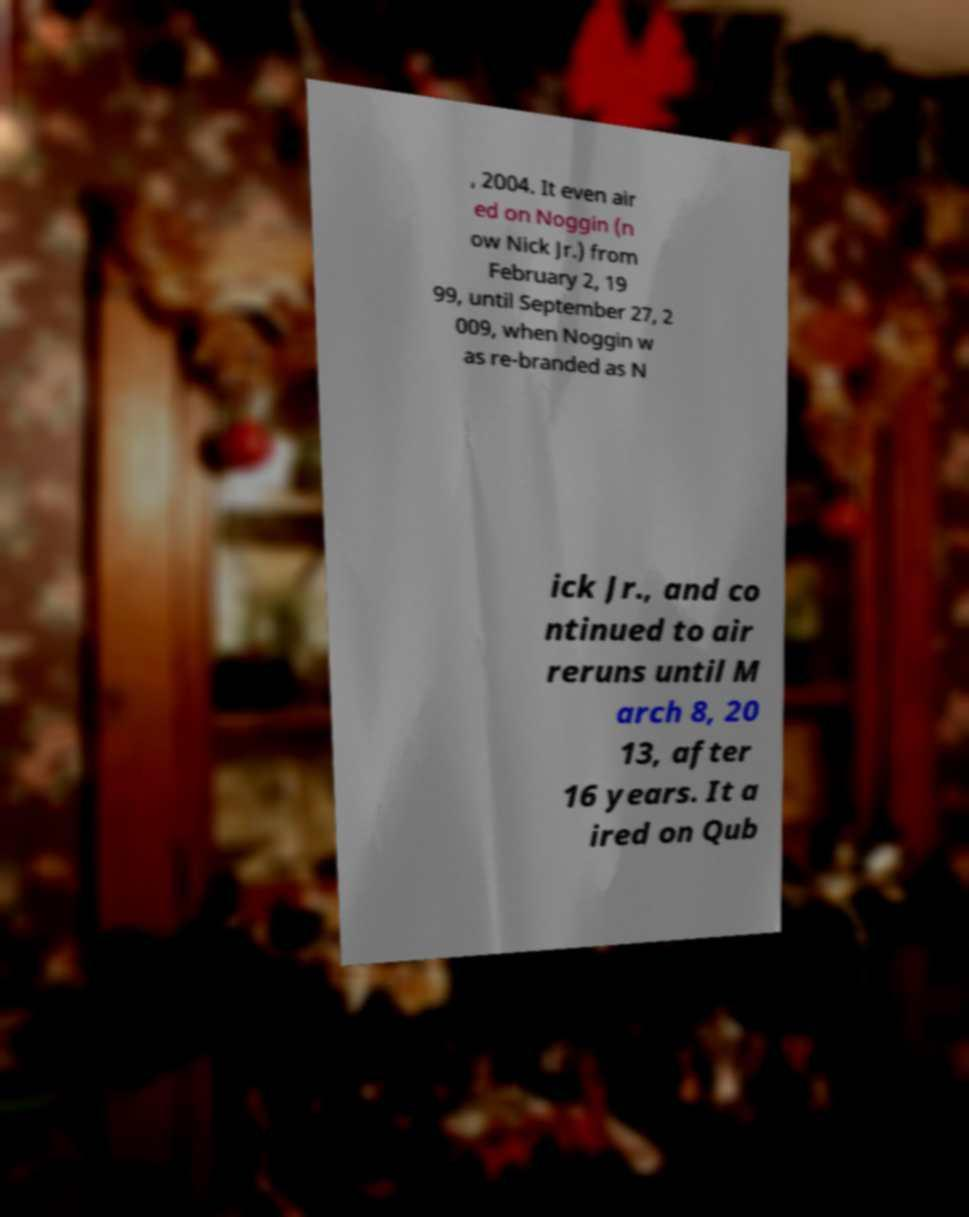Please read and relay the text visible in this image. What does it say? , 2004. It even air ed on Noggin (n ow Nick Jr.) from February 2, 19 99, until September 27, 2 009, when Noggin w as re-branded as N ick Jr., and co ntinued to air reruns until M arch 8, 20 13, after 16 years. It a ired on Qub 